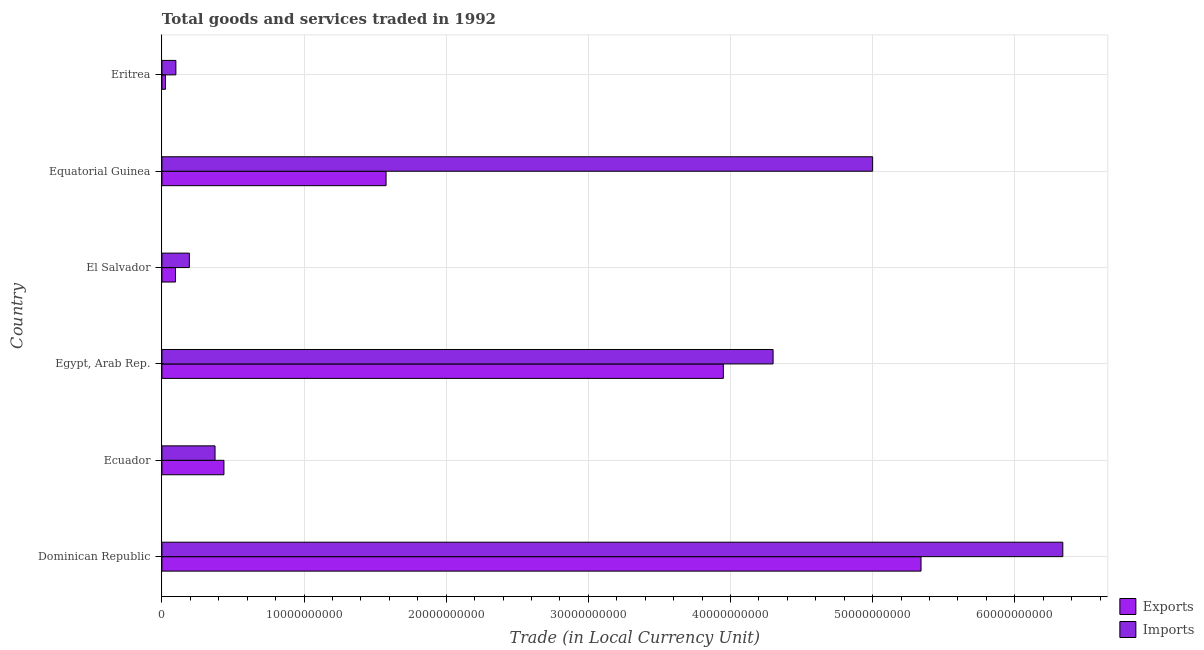How many different coloured bars are there?
Make the answer very short. 2. Are the number of bars per tick equal to the number of legend labels?
Keep it short and to the point. Yes. Are the number of bars on each tick of the Y-axis equal?
Your answer should be compact. Yes. How many bars are there on the 2nd tick from the bottom?
Your answer should be very brief. 2. What is the label of the 1st group of bars from the top?
Your answer should be compact. Eritrea. What is the imports of goods and services in Ecuador?
Provide a short and direct response. 3.74e+09. Across all countries, what is the maximum export of goods and services?
Give a very brief answer. 5.34e+1. Across all countries, what is the minimum export of goods and services?
Keep it short and to the point. 2.50e+08. In which country was the export of goods and services maximum?
Offer a very short reply. Dominican Republic. In which country was the export of goods and services minimum?
Your answer should be very brief. Eritrea. What is the total export of goods and services in the graph?
Provide a short and direct response. 1.14e+11. What is the difference between the imports of goods and services in Dominican Republic and that in Ecuador?
Give a very brief answer. 5.96e+1. What is the difference between the imports of goods and services in Ecuador and the export of goods and services in Dominican Republic?
Provide a short and direct response. -4.97e+1. What is the average export of goods and services per country?
Offer a terse response. 1.90e+1. What is the difference between the export of goods and services and imports of goods and services in El Salvador?
Give a very brief answer. -9.73e+08. What is the ratio of the imports of goods and services in El Salvador to that in Eritrea?
Offer a very short reply. 1.97. What is the difference between the highest and the second highest imports of goods and services?
Keep it short and to the point. 1.34e+1. What is the difference between the highest and the lowest imports of goods and services?
Give a very brief answer. 6.24e+1. What does the 1st bar from the top in Ecuador represents?
Offer a very short reply. Imports. What does the 2nd bar from the bottom in Egypt, Arab Rep. represents?
Keep it short and to the point. Imports. How many bars are there?
Your answer should be compact. 12. Are all the bars in the graph horizontal?
Keep it short and to the point. Yes. How many countries are there in the graph?
Provide a short and direct response. 6. What is the difference between two consecutive major ticks on the X-axis?
Provide a succinct answer. 1.00e+1. How many legend labels are there?
Make the answer very short. 2. How are the legend labels stacked?
Your answer should be compact. Vertical. What is the title of the graph?
Offer a very short reply. Total goods and services traded in 1992. What is the label or title of the X-axis?
Provide a succinct answer. Trade (in Local Currency Unit). What is the label or title of the Y-axis?
Your answer should be compact. Country. What is the Trade (in Local Currency Unit) of Exports in Dominican Republic?
Provide a short and direct response. 5.34e+1. What is the Trade (in Local Currency Unit) in Imports in Dominican Republic?
Provide a short and direct response. 6.34e+1. What is the Trade (in Local Currency Unit) in Exports in Ecuador?
Ensure brevity in your answer.  4.36e+09. What is the Trade (in Local Currency Unit) of Imports in Ecuador?
Give a very brief answer. 3.74e+09. What is the Trade (in Local Currency Unit) in Exports in Egypt, Arab Rep.?
Give a very brief answer. 3.95e+1. What is the Trade (in Local Currency Unit) of Imports in Egypt, Arab Rep.?
Your answer should be compact. 4.30e+1. What is the Trade (in Local Currency Unit) in Exports in El Salvador?
Offer a terse response. 9.58e+08. What is the Trade (in Local Currency Unit) of Imports in El Salvador?
Provide a succinct answer. 1.93e+09. What is the Trade (in Local Currency Unit) of Exports in Equatorial Guinea?
Offer a terse response. 1.58e+1. What is the Trade (in Local Currency Unit) of Imports in Equatorial Guinea?
Your response must be concise. 5.00e+1. What is the Trade (in Local Currency Unit) in Exports in Eritrea?
Offer a terse response. 2.50e+08. What is the Trade (in Local Currency Unit) in Imports in Eritrea?
Your answer should be very brief. 9.83e+08. Across all countries, what is the maximum Trade (in Local Currency Unit) of Exports?
Your response must be concise. 5.34e+1. Across all countries, what is the maximum Trade (in Local Currency Unit) of Imports?
Your answer should be compact. 6.34e+1. Across all countries, what is the minimum Trade (in Local Currency Unit) in Exports?
Make the answer very short. 2.50e+08. Across all countries, what is the minimum Trade (in Local Currency Unit) in Imports?
Your answer should be very brief. 9.83e+08. What is the total Trade (in Local Currency Unit) in Exports in the graph?
Give a very brief answer. 1.14e+11. What is the total Trade (in Local Currency Unit) of Imports in the graph?
Keep it short and to the point. 1.63e+11. What is the difference between the Trade (in Local Currency Unit) of Exports in Dominican Republic and that in Ecuador?
Your answer should be very brief. 4.90e+1. What is the difference between the Trade (in Local Currency Unit) in Imports in Dominican Republic and that in Ecuador?
Your answer should be compact. 5.96e+1. What is the difference between the Trade (in Local Currency Unit) in Exports in Dominican Republic and that in Egypt, Arab Rep.?
Keep it short and to the point. 1.39e+1. What is the difference between the Trade (in Local Currency Unit) in Imports in Dominican Republic and that in Egypt, Arab Rep.?
Offer a very short reply. 2.04e+1. What is the difference between the Trade (in Local Currency Unit) in Exports in Dominican Republic and that in El Salvador?
Your answer should be very brief. 5.25e+1. What is the difference between the Trade (in Local Currency Unit) in Imports in Dominican Republic and that in El Salvador?
Keep it short and to the point. 6.15e+1. What is the difference between the Trade (in Local Currency Unit) in Exports in Dominican Republic and that in Equatorial Guinea?
Your response must be concise. 3.76e+1. What is the difference between the Trade (in Local Currency Unit) of Imports in Dominican Republic and that in Equatorial Guinea?
Ensure brevity in your answer.  1.34e+1. What is the difference between the Trade (in Local Currency Unit) in Exports in Dominican Republic and that in Eritrea?
Keep it short and to the point. 5.32e+1. What is the difference between the Trade (in Local Currency Unit) in Imports in Dominican Republic and that in Eritrea?
Keep it short and to the point. 6.24e+1. What is the difference between the Trade (in Local Currency Unit) of Exports in Ecuador and that in Egypt, Arab Rep.?
Your answer should be compact. -3.51e+1. What is the difference between the Trade (in Local Currency Unit) of Imports in Ecuador and that in Egypt, Arab Rep.?
Provide a short and direct response. -3.93e+1. What is the difference between the Trade (in Local Currency Unit) in Exports in Ecuador and that in El Salvador?
Your response must be concise. 3.41e+09. What is the difference between the Trade (in Local Currency Unit) of Imports in Ecuador and that in El Salvador?
Keep it short and to the point. 1.81e+09. What is the difference between the Trade (in Local Currency Unit) in Exports in Ecuador and that in Equatorial Guinea?
Offer a terse response. -1.14e+1. What is the difference between the Trade (in Local Currency Unit) of Imports in Ecuador and that in Equatorial Guinea?
Provide a short and direct response. -4.63e+1. What is the difference between the Trade (in Local Currency Unit) of Exports in Ecuador and that in Eritrea?
Offer a terse response. 4.11e+09. What is the difference between the Trade (in Local Currency Unit) of Imports in Ecuador and that in Eritrea?
Make the answer very short. 2.76e+09. What is the difference between the Trade (in Local Currency Unit) in Exports in Egypt, Arab Rep. and that in El Salvador?
Your response must be concise. 3.85e+1. What is the difference between the Trade (in Local Currency Unit) of Imports in Egypt, Arab Rep. and that in El Salvador?
Give a very brief answer. 4.11e+1. What is the difference between the Trade (in Local Currency Unit) of Exports in Egypt, Arab Rep. and that in Equatorial Guinea?
Give a very brief answer. 2.37e+1. What is the difference between the Trade (in Local Currency Unit) of Imports in Egypt, Arab Rep. and that in Equatorial Guinea?
Your response must be concise. -7.00e+09. What is the difference between the Trade (in Local Currency Unit) of Exports in Egypt, Arab Rep. and that in Eritrea?
Ensure brevity in your answer.  3.93e+1. What is the difference between the Trade (in Local Currency Unit) in Imports in Egypt, Arab Rep. and that in Eritrea?
Provide a short and direct response. 4.20e+1. What is the difference between the Trade (in Local Currency Unit) of Exports in El Salvador and that in Equatorial Guinea?
Ensure brevity in your answer.  -1.48e+1. What is the difference between the Trade (in Local Currency Unit) of Imports in El Salvador and that in Equatorial Guinea?
Offer a very short reply. -4.81e+1. What is the difference between the Trade (in Local Currency Unit) of Exports in El Salvador and that in Eritrea?
Provide a succinct answer. 7.08e+08. What is the difference between the Trade (in Local Currency Unit) of Imports in El Salvador and that in Eritrea?
Provide a short and direct response. 9.48e+08. What is the difference between the Trade (in Local Currency Unit) of Exports in Equatorial Guinea and that in Eritrea?
Ensure brevity in your answer.  1.55e+1. What is the difference between the Trade (in Local Currency Unit) of Imports in Equatorial Guinea and that in Eritrea?
Ensure brevity in your answer.  4.90e+1. What is the difference between the Trade (in Local Currency Unit) in Exports in Dominican Republic and the Trade (in Local Currency Unit) in Imports in Ecuador?
Provide a short and direct response. 4.97e+1. What is the difference between the Trade (in Local Currency Unit) in Exports in Dominican Republic and the Trade (in Local Currency Unit) in Imports in Egypt, Arab Rep.?
Your answer should be very brief. 1.04e+1. What is the difference between the Trade (in Local Currency Unit) in Exports in Dominican Republic and the Trade (in Local Currency Unit) in Imports in El Salvador?
Provide a succinct answer. 5.15e+1. What is the difference between the Trade (in Local Currency Unit) in Exports in Dominican Republic and the Trade (in Local Currency Unit) in Imports in Equatorial Guinea?
Provide a short and direct response. 3.40e+09. What is the difference between the Trade (in Local Currency Unit) in Exports in Dominican Republic and the Trade (in Local Currency Unit) in Imports in Eritrea?
Offer a very short reply. 5.24e+1. What is the difference between the Trade (in Local Currency Unit) of Exports in Ecuador and the Trade (in Local Currency Unit) of Imports in Egypt, Arab Rep.?
Offer a terse response. -3.86e+1. What is the difference between the Trade (in Local Currency Unit) of Exports in Ecuador and the Trade (in Local Currency Unit) of Imports in El Salvador?
Your answer should be compact. 2.43e+09. What is the difference between the Trade (in Local Currency Unit) of Exports in Ecuador and the Trade (in Local Currency Unit) of Imports in Equatorial Guinea?
Your response must be concise. -4.56e+1. What is the difference between the Trade (in Local Currency Unit) in Exports in Ecuador and the Trade (in Local Currency Unit) in Imports in Eritrea?
Your answer should be very brief. 3.38e+09. What is the difference between the Trade (in Local Currency Unit) of Exports in Egypt, Arab Rep. and the Trade (in Local Currency Unit) of Imports in El Salvador?
Your answer should be compact. 3.76e+1. What is the difference between the Trade (in Local Currency Unit) in Exports in Egypt, Arab Rep. and the Trade (in Local Currency Unit) in Imports in Equatorial Guinea?
Offer a very short reply. -1.05e+1. What is the difference between the Trade (in Local Currency Unit) of Exports in Egypt, Arab Rep. and the Trade (in Local Currency Unit) of Imports in Eritrea?
Offer a terse response. 3.85e+1. What is the difference between the Trade (in Local Currency Unit) in Exports in El Salvador and the Trade (in Local Currency Unit) in Imports in Equatorial Guinea?
Give a very brief answer. -4.90e+1. What is the difference between the Trade (in Local Currency Unit) of Exports in El Salvador and the Trade (in Local Currency Unit) of Imports in Eritrea?
Keep it short and to the point. -2.49e+07. What is the difference between the Trade (in Local Currency Unit) in Exports in Equatorial Guinea and the Trade (in Local Currency Unit) in Imports in Eritrea?
Provide a succinct answer. 1.48e+1. What is the average Trade (in Local Currency Unit) of Exports per country?
Offer a terse response. 1.90e+1. What is the average Trade (in Local Currency Unit) of Imports per country?
Your response must be concise. 2.72e+1. What is the difference between the Trade (in Local Currency Unit) of Exports and Trade (in Local Currency Unit) of Imports in Dominican Republic?
Provide a succinct answer. -9.97e+09. What is the difference between the Trade (in Local Currency Unit) in Exports and Trade (in Local Currency Unit) in Imports in Ecuador?
Offer a very short reply. 6.26e+08. What is the difference between the Trade (in Local Currency Unit) of Exports and Trade (in Local Currency Unit) of Imports in Egypt, Arab Rep.?
Provide a succinct answer. -3.50e+09. What is the difference between the Trade (in Local Currency Unit) in Exports and Trade (in Local Currency Unit) in Imports in El Salvador?
Provide a succinct answer. -9.73e+08. What is the difference between the Trade (in Local Currency Unit) in Exports and Trade (in Local Currency Unit) in Imports in Equatorial Guinea?
Provide a succinct answer. -3.42e+1. What is the difference between the Trade (in Local Currency Unit) of Exports and Trade (in Local Currency Unit) of Imports in Eritrea?
Make the answer very short. -7.33e+08. What is the ratio of the Trade (in Local Currency Unit) in Exports in Dominican Republic to that in Ecuador?
Keep it short and to the point. 12.24. What is the ratio of the Trade (in Local Currency Unit) of Imports in Dominican Republic to that in Ecuador?
Provide a short and direct response. 16.95. What is the ratio of the Trade (in Local Currency Unit) of Exports in Dominican Republic to that in Egypt, Arab Rep.?
Your answer should be very brief. 1.35. What is the ratio of the Trade (in Local Currency Unit) in Imports in Dominican Republic to that in Egypt, Arab Rep.?
Your response must be concise. 1.47. What is the ratio of the Trade (in Local Currency Unit) of Exports in Dominican Republic to that in El Salvador?
Your response must be concise. 55.74. What is the ratio of the Trade (in Local Currency Unit) in Imports in Dominican Republic to that in El Salvador?
Give a very brief answer. 32.82. What is the ratio of the Trade (in Local Currency Unit) in Exports in Dominican Republic to that in Equatorial Guinea?
Make the answer very short. 3.39. What is the ratio of the Trade (in Local Currency Unit) in Imports in Dominican Republic to that in Equatorial Guinea?
Your answer should be very brief. 1.27. What is the ratio of the Trade (in Local Currency Unit) of Exports in Dominican Republic to that in Eritrea?
Your answer should be compact. 213.8. What is the ratio of the Trade (in Local Currency Unit) in Imports in Dominican Republic to that in Eritrea?
Your answer should be compact. 64.48. What is the ratio of the Trade (in Local Currency Unit) in Exports in Ecuador to that in Egypt, Arab Rep.?
Keep it short and to the point. 0.11. What is the ratio of the Trade (in Local Currency Unit) of Imports in Ecuador to that in Egypt, Arab Rep.?
Provide a short and direct response. 0.09. What is the ratio of the Trade (in Local Currency Unit) in Exports in Ecuador to that in El Salvador?
Offer a very short reply. 4.56. What is the ratio of the Trade (in Local Currency Unit) of Imports in Ecuador to that in El Salvador?
Keep it short and to the point. 1.94. What is the ratio of the Trade (in Local Currency Unit) of Exports in Ecuador to that in Equatorial Guinea?
Give a very brief answer. 0.28. What is the ratio of the Trade (in Local Currency Unit) in Imports in Ecuador to that in Equatorial Guinea?
Offer a very short reply. 0.07. What is the ratio of the Trade (in Local Currency Unit) of Exports in Ecuador to that in Eritrea?
Your answer should be compact. 17.47. What is the ratio of the Trade (in Local Currency Unit) of Imports in Ecuador to that in Eritrea?
Offer a terse response. 3.8. What is the ratio of the Trade (in Local Currency Unit) in Exports in Egypt, Arab Rep. to that in El Salvador?
Offer a very short reply. 41.23. What is the ratio of the Trade (in Local Currency Unit) in Imports in Egypt, Arab Rep. to that in El Salvador?
Offer a very short reply. 22.26. What is the ratio of the Trade (in Local Currency Unit) in Exports in Egypt, Arab Rep. to that in Equatorial Guinea?
Give a very brief answer. 2.5. What is the ratio of the Trade (in Local Currency Unit) of Imports in Egypt, Arab Rep. to that in Equatorial Guinea?
Provide a succinct answer. 0.86. What is the ratio of the Trade (in Local Currency Unit) in Exports in Egypt, Arab Rep. to that in Eritrea?
Make the answer very short. 158.13. What is the ratio of the Trade (in Local Currency Unit) of Imports in Egypt, Arab Rep. to that in Eritrea?
Offer a very short reply. 43.74. What is the ratio of the Trade (in Local Currency Unit) in Exports in El Salvador to that in Equatorial Guinea?
Ensure brevity in your answer.  0.06. What is the ratio of the Trade (in Local Currency Unit) of Imports in El Salvador to that in Equatorial Guinea?
Offer a terse response. 0.04. What is the ratio of the Trade (in Local Currency Unit) in Exports in El Salvador to that in Eritrea?
Your response must be concise. 3.84. What is the ratio of the Trade (in Local Currency Unit) in Imports in El Salvador to that in Eritrea?
Make the answer very short. 1.96. What is the ratio of the Trade (in Local Currency Unit) of Exports in Equatorial Guinea to that in Eritrea?
Provide a short and direct response. 63.14. What is the ratio of the Trade (in Local Currency Unit) of Imports in Equatorial Guinea to that in Eritrea?
Give a very brief answer. 50.87. What is the difference between the highest and the second highest Trade (in Local Currency Unit) in Exports?
Make the answer very short. 1.39e+1. What is the difference between the highest and the second highest Trade (in Local Currency Unit) in Imports?
Offer a very short reply. 1.34e+1. What is the difference between the highest and the lowest Trade (in Local Currency Unit) of Exports?
Make the answer very short. 5.32e+1. What is the difference between the highest and the lowest Trade (in Local Currency Unit) of Imports?
Keep it short and to the point. 6.24e+1. 